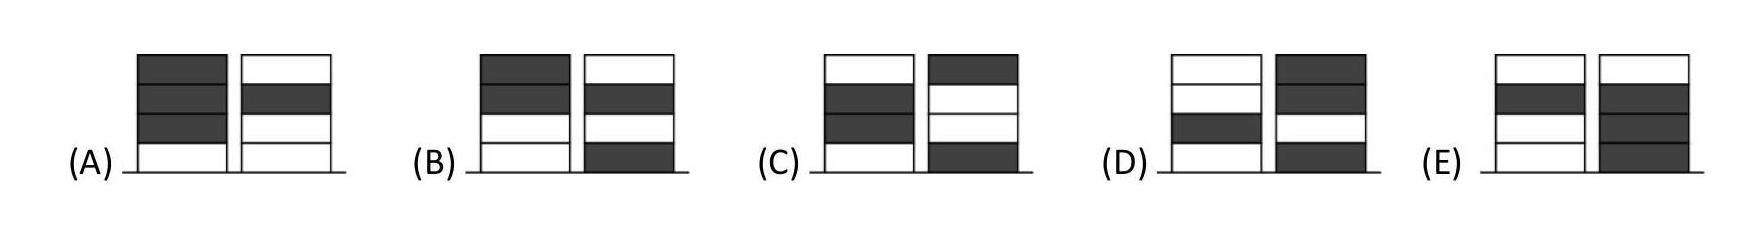Ronja had four white tokens and Wanja had four grey tokens. They played a game in which they took turns to place one of their tokens to create two piles. Ronja placed her first token first. Which pair of piles could they not create?
Choices: ['A', 'B', 'C', 'D', 'E'] Answer is E. 